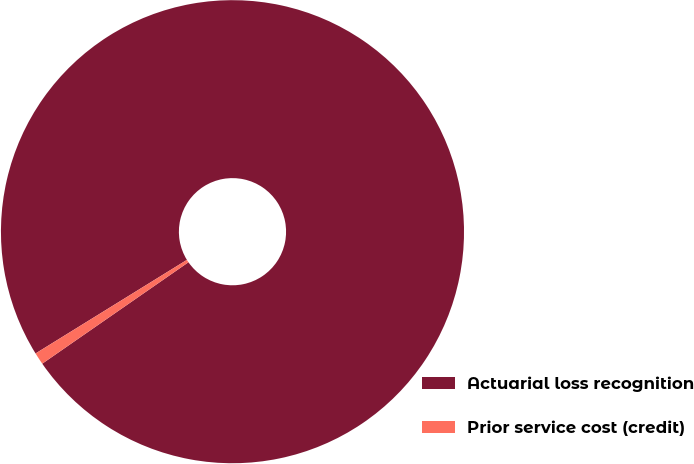Convert chart. <chart><loc_0><loc_0><loc_500><loc_500><pie_chart><fcel>Actuarial loss recognition<fcel>Prior service cost (credit)<nl><fcel>99.16%<fcel>0.84%<nl></chart> 